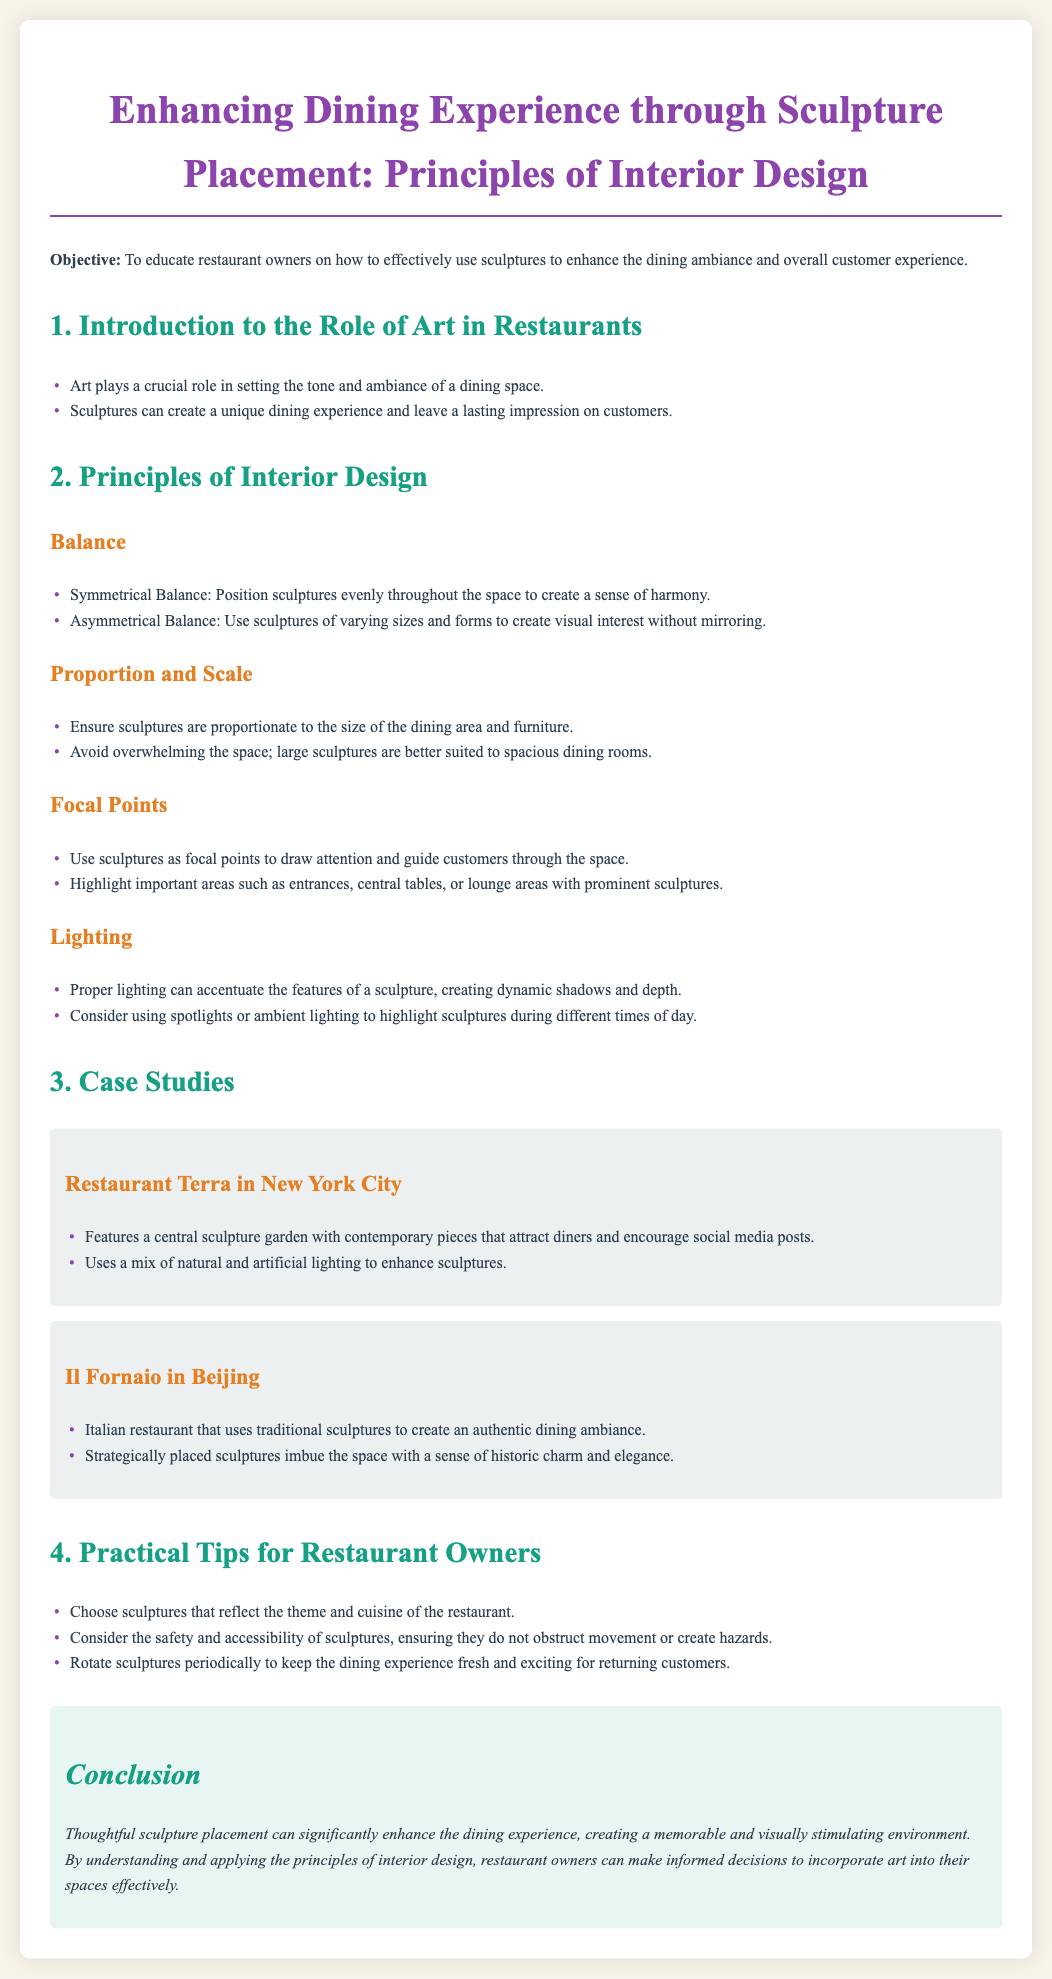What is the main objective of the lesson plan? The objective is to educate restaurant owners on how to effectively use sculptures to enhance the dining ambiance and overall customer experience.
Answer: To educate restaurant owners on how to effectively use sculptures to enhance the dining ambiance and overall customer experience What are the two types of balance discussed in the document? The document mentions symmetrical balance and asymmetrical balance as types of balance in interior design.
Answer: Symmetrical balance and asymmetrical balance Which restaurant features a central sculpture garden? Restaurant Terra in New York City is highlighted for its central sculpture garden with contemporary pieces.
Answer: Restaurant Terra in New York City What does proper lighting do for sculptures? The document states that proper lighting can accentuate the features of a sculpture, creating dynamic shadows and depth.
Answer: Accentuate the features of a sculpture What practical tip is given regarding the rotation of sculptures? One of the practical tips suggests rotating sculptures periodically to keep the dining experience fresh and exciting for returning customers.
Answer: Rotate sculptures periodically 